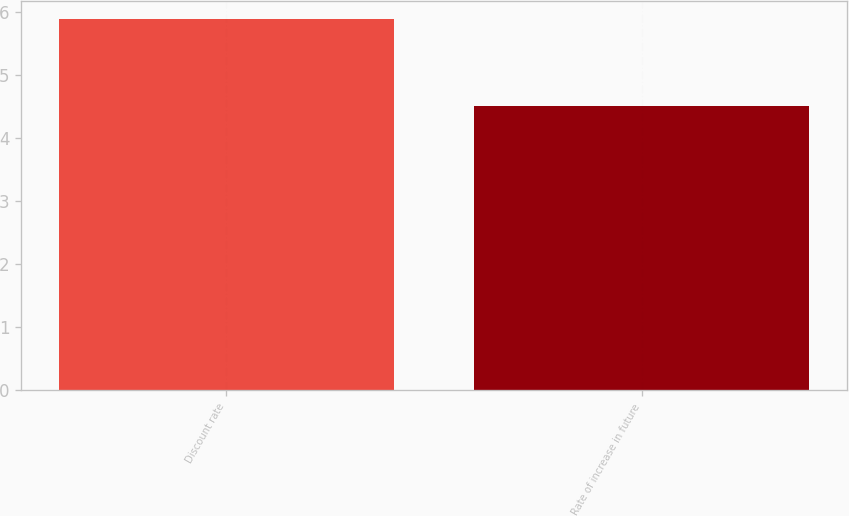<chart> <loc_0><loc_0><loc_500><loc_500><bar_chart><fcel>Discount rate<fcel>Rate of increase in future<nl><fcel>5.88<fcel>4.5<nl></chart> 